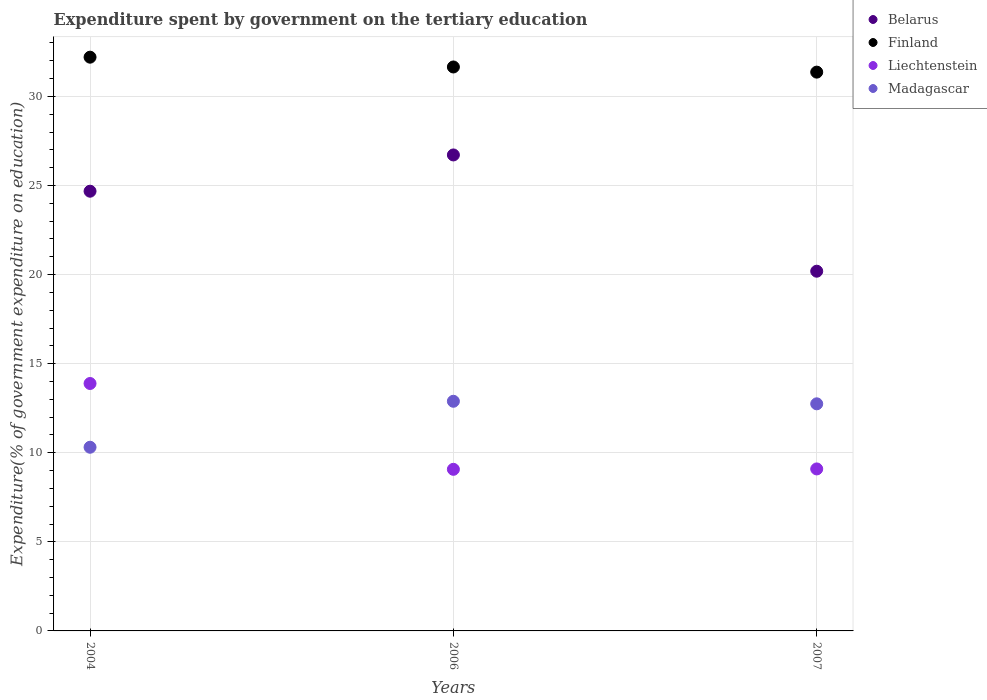What is the expenditure spent by government on the tertiary education in Finland in 2006?
Your response must be concise. 31.65. Across all years, what is the maximum expenditure spent by government on the tertiary education in Liechtenstein?
Keep it short and to the point. 13.89. Across all years, what is the minimum expenditure spent by government on the tertiary education in Finland?
Your response must be concise. 31.36. What is the total expenditure spent by government on the tertiary education in Finland in the graph?
Give a very brief answer. 95.22. What is the difference between the expenditure spent by government on the tertiary education in Belarus in 2004 and that in 2007?
Provide a short and direct response. 4.49. What is the difference between the expenditure spent by government on the tertiary education in Madagascar in 2004 and the expenditure spent by government on the tertiary education in Liechtenstein in 2007?
Your answer should be very brief. 1.22. What is the average expenditure spent by government on the tertiary education in Belarus per year?
Provide a short and direct response. 23.86. In the year 2007, what is the difference between the expenditure spent by government on the tertiary education in Liechtenstein and expenditure spent by government on the tertiary education in Finland?
Keep it short and to the point. -22.27. What is the ratio of the expenditure spent by government on the tertiary education in Liechtenstein in 2006 to that in 2007?
Your answer should be compact. 1. Is the expenditure spent by government on the tertiary education in Liechtenstein in 2006 less than that in 2007?
Offer a terse response. Yes. What is the difference between the highest and the second highest expenditure spent by government on the tertiary education in Liechtenstein?
Provide a succinct answer. 4.79. What is the difference between the highest and the lowest expenditure spent by government on the tertiary education in Madagascar?
Keep it short and to the point. 2.58. In how many years, is the expenditure spent by government on the tertiary education in Liechtenstein greater than the average expenditure spent by government on the tertiary education in Liechtenstein taken over all years?
Provide a short and direct response. 1. Is the sum of the expenditure spent by government on the tertiary education in Belarus in 2004 and 2007 greater than the maximum expenditure spent by government on the tertiary education in Liechtenstein across all years?
Provide a succinct answer. Yes. Is the expenditure spent by government on the tertiary education in Belarus strictly greater than the expenditure spent by government on the tertiary education in Madagascar over the years?
Provide a succinct answer. Yes. Is the expenditure spent by government on the tertiary education in Liechtenstein strictly less than the expenditure spent by government on the tertiary education in Madagascar over the years?
Give a very brief answer. No. How many legend labels are there?
Ensure brevity in your answer.  4. How are the legend labels stacked?
Offer a very short reply. Vertical. What is the title of the graph?
Provide a succinct answer. Expenditure spent by government on the tertiary education. What is the label or title of the X-axis?
Offer a terse response. Years. What is the label or title of the Y-axis?
Provide a succinct answer. Expenditure(% of government expenditure on education). What is the Expenditure(% of government expenditure on education) of Belarus in 2004?
Offer a terse response. 24.68. What is the Expenditure(% of government expenditure on education) in Finland in 2004?
Your response must be concise. 32.2. What is the Expenditure(% of government expenditure on education) of Liechtenstein in 2004?
Your response must be concise. 13.89. What is the Expenditure(% of government expenditure on education) in Madagascar in 2004?
Offer a terse response. 10.31. What is the Expenditure(% of government expenditure on education) in Belarus in 2006?
Provide a succinct answer. 26.71. What is the Expenditure(% of government expenditure on education) in Finland in 2006?
Offer a very short reply. 31.65. What is the Expenditure(% of government expenditure on education) of Liechtenstein in 2006?
Your answer should be very brief. 9.07. What is the Expenditure(% of government expenditure on education) of Madagascar in 2006?
Keep it short and to the point. 12.89. What is the Expenditure(% of government expenditure on education) of Belarus in 2007?
Keep it short and to the point. 20.19. What is the Expenditure(% of government expenditure on education) in Finland in 2007?
Give a very brief answer. 31.36. What is the Expenditure(% of government expenditure on education) in Liechtenstein in 2007?
Provide a succinct answer. 9.09. What is the Expenditure(% of government expenditure on education) in Madagascar in 2007?
Ensure brevity in your answer.  12.75. Across all years, what is the maximum Expenditure(% of government expenditure on education) of Belarus?
Your response must be concise. 26.71. Across all years, what is the maximum Expenditure(% of government expenditure on education) in Finland?
Offer a terse response. 32.2. Across all years, what is the maximum Expenditure(% of government expenditure on education) in Liechtenstein?
Your response must be concise. 13.89. Across all years, what is the maximum Expenditure(% of government expenditure on education) in Madagascar?
Your answer should be compact. 12.89. Across all years, what is the minimum Expenditure(% of government expenditure on education) in Belarus?
Give a very brief answer. 20.19. Across all years, what is the minimum Expenditure(% of government expenditure on education) of Finland?
Your answer should be very brief. 31.36. Across all years, what is the minimum Expenditure(% of government expenditure on education) in Liechtenstein?
Offer a very short reply. 9.07. Across all years, what is the minimum Expenditure(% of government expenditure on education) of Madagascar?
Your answer should be very brief. 10.31. What is the total Expenditure(% of government expenditure on education) in Belarus in the graph?
Make the answer very short. 71.58. What is the total Expenditure(% of government expenditure on education) of Finland in the graph?
Ensure brevity in your answer.  95.22. What is the total Expenditure(% of government expenditure on education) in Liechtenstein in the graph?
Keep it short and to the point. 32.05. What is the total Expenditure(% of government expenditure on education) of Madagascar in the graph?
Provide a short and direct response. 35.95. What is the difference between the Expenditure(% of government expenditure on education) of Belarus in 2004 and that in 2006?
Provide a short and direct response. -2.04. What is the difference between the Expenditure(% of government expenditure on education) of Finland in 2004 and that in 2006?
Make the answer very short. 0.55. What is the difference between the Expenditure(% of government expenditure on education) in Liechtenstein in 2004 and that in 2006?
Offer a very short reply. 4.82. What is the difference between the Expenditure(% of government expenditure on education) in Madagascar in 2004 and that in 2006?
Ensure brevity in your answer.  -2.58. What is the difference between the Expenditure(% of government expenditure on education) in Belarus in 2004 and that in 2007?
Offer a very short reply. 4.49. What is the difference between the Expenditure(% of government expenditure on education) in Finland in 2004 and that in 2007?
Offer a terse response. 0.84. What is the difference between the Expenditure(% of government expenditure on education) of Liechtenstein in 2004 and that in 2007?
Your answer should be compact. 4.79. What is the difference between the Expenditure(% of government expenditure on education) of Madagascar in 2004 and that in 2007?
Offer a very short reply. -2.44. What is the difference between the Expenditure(% of government expenditure on education) in Belarus in 2006 and that in 2007?
Make the answer very short. 6.53. What is the difference between the Expenditure(% of government expenditure on education) of Finland in 2006 and that in 2007?
Give a very brief answer. 0.29. What is the difference between the Expenditure(% of government expenditure on education) in Liechtenstein in 2006 and that in 2007?
Give a very brief answer. -0.02. What is the difference between the Expenditure(% of government expenditure on education) in Madagascar in 2006 and that in 2007?
Provide a short and direct response. 0.14. What is the difference between the Expenditure(% of government expenditure on education) of Belarus in 2004 and the Expenditure(% of government expenditure on education) of Finland in 2006?
Keep it short and to the point. -6.97. What is the difference between the Expenditure(% of government expenditure on education) of Belarus in 2004 and the Expenditure(% of government expenditure on education) of Liechtenstein in 2006?
Keep it short and to the point. 15.61. What is the difference between the Expenditure(% of government expenditure on education) of Belarus in 2004 and the Expenditure(% of government expenditure on education) of Madagascar in 2006?
Provide a short and direct response. 11.79. What is the difference between the Expenditure(% of government expenditure on education) in Finland in 2004 and the Expenditure(% of government expenditure on education) in Liechtenstein in 2006?
Your response must be concise. 23.13. What is the difference between the Expenditure(% of government expenditure on education) of Finland in 2004 and the Expenditure(% of government expenditure on education) of Madagascar in 2006?
Make the answer very short. 19.31. What is the difference between the Expenditure(% of government expenditure on education) in Belarus in 2004 and the Expenditure(% of government expenditure on education) in Finland in 2007?
Your response must be concise. -6.68. What is the difference between the Expenditure(% of government expenditure on education) of Belarus in 2004 and the Expenditure(% of government expenditure on education) of Liechtenstein in 2007?
Keep it short and to the point. 15.59. What is the difference between the Expenditure(% of government expenditure on education) in Belarus in 2004 and the Expenditure(% of government expenditure on education) in Madagascar in 2007?
Provide a succinct answer. 11.93. What is the difference between the Expenditure(% of government expenditure on education) in Finland in 2004 and the Expenditure(% of government expenditure on education) in Liechtenstein in 2007?
Make the answer very short. 23.11. What is the difference between the Expenditure(% of government expenditure on education) of Finland in 2004 and the Expenditure(% of government expenditure on education) of Madagascar in 2007?
Provide a succinct answer. 19.45. What is the difference between the Expenditure(% of government expenditure on education) in Liechtenstein in 2004 and the Expenditure(% of government expenditure on education) in Madagascar in 2007?
Offer a very short reply. 1.14. What is the difference between the Expenditure(% of government expenditure on education) in Belarus in 2006 and the Expenditure(% of government expenditure on education) in Finland in 2007?
Your answer should be compact. -4.65. What is the difference between the Expenditure(% of government expenditure on education) in Belarus in 2006 and the Expenditure(% of government expenditure on education) in Liechtenstein in 2007?
Give a very brief answer. 17.62. What is the difference between the Expenditure(% of government expenditure on education) of Belarus in 2006 and the Expenditure(% of government expenditure on education) of Madagascar in 2007?
Offer a terse response. 13.97. What is the difference between the Expenditure(% of government expenditure on education) in Finland in 2006 and the Expenditure(% of government expenditure on education) in Liechtenstein in 2007?
Keep it short and to the point. 22.56. What is the difference between the Expenditure(% of government expenditure on education) of Finland in 2006 and the Expenditure(% of government expenditure on education) of Madagascar in 2007?
Ensure brevity in your answer.  18.91. What is the difference between the Expenditure(% of government expenditure on education) in Liechtenstein in 2006 and the Expenditure(% of government expenditure on education) in Madagascar in 2007?
Your answer should be very brief. -3.68. What is the average Expenditure(% of government expenditure on education) in Belarus per year?
Keep it short and to the point. 23.86. What is the average Expenditure(% of government expenditure on education) of Finland per year?
Your answer should be compact. 31.74. What is the average Expenditure(% of government expenditure on education) of Liechtenstein per year?
Provide a succinct answer. 10.68. What is the average Expenditure(% of government expenditure on education) of Madagascar per year?
Keep it short and to the point. 11.98. In the year 2004, what is the difference between the Expenditure(% of government expenditure on education) of Belarus and Expenditure(% of government expenditure on education) of Finland?
Provide a succinct answer. -7.52. In the year 2004, what is the difference between the Expenditure(% of government expenditure on education) of Belarus and Expenditure(% of government expenditure on education) of Liechtenstein?
Your answer should be very brief. 10.79. In the year 2004, what is the difference between the Expenditure(% of government expenditure on education) of Belarus and Expenditure(% of government expenditure on education) of Madagascar?
Offer a terse response. 14.37. In the year 2004, what is the difference between the Expenditure(% of government expenditure on education) of Finland and Expenditure(% of government expenditure on education) of Liechtenstein?
Make the answer very short. 18.31. In the year 2004, what is the difference between the Expenditure(% of government expenditure on education) in Finland and Expenditure(% of government expenditure on education) in Madagascar?
Provide a succinct answer. 21.89. In the year 2004, what is the difference between the Expenditure(% of government expenditure on education) in Liechtenstein and Expenditure(% of government expenditure on education) in Madagascar?
Offer a terse response. 3.58. In the year 2006, what is the difference between the Expenditure(% of government expenditure on education) of Belarus and Expenditure(% of government expenditure on education) of Finland?
Your answer should be very brief. -4.94. In the year 2006, what is the difference between the Expenditure(% of government expenditure on education) of Belarus and Expenditure(% of government expenditure on education) of Liechtenstein?
Make the answer very short. 17.64. In the year 2006, what is the difference between the Expenditure(% of government expenditure on education) in Belarus and Expenditure(% of government expenditure on education) in Madagascar?
Offer a terse response. 13.83. In the year 2006, what is the difference between the Expenditure(% of government expenditure on education) of Finland and Expenditure(% of government expenditure on education) of Liechtenstein?
Your answer should be compact. 22.58. In the year 2006, what is the difference between the Expenditure(% of government expenditure on education) of Finland and Expenditure(% of government expenditure on education) of Madagascar?
Offer a very short reply. 18.76. In the year 2006, what is the difference between the Expenditure(% of government expenditure on education) in Liechtenstein and Expenditure(% of government expenditure on education) in Madagascar?
Provide a succinct answer. -3.82. In the year 2007, what is the difference between the Expenditure(% of government expenditure on education) of Belarus and Expenditure(% of government expenditure on education) of Finland?
Your answer should be compact. -11.17. In the year 2007, what is the difference between the Expenditure(% of government expenditure on education) of Belarus and Expenditure(% of government expenditure on education) of Liechtenstein?
Provide a succinct answer. 11.1. In the year 2007, what is the difference between the Expenditure(% of government expenditure on education) of Belarus and Expenditure(% of government expenditure on education) of Madagascar?
Provide a succinct answer. 7.44. In the year 2007, what is the difference between the Expenditure(% of government expenditure on education) of Finland and Expenditure(% of government expenditure on education) of Liechtenstein?
Your answer should be compact. 22.27. In the year 2007, what is the difference between the Expenditure(% of government expenditure on education) of Finland and Expenditure(% of government expenditure on education) of Madagascar?
Make the answer very short. 18.62. In the year 2007, what is the difference between the Expenditure(% of government expenditure on education) of Liechtenstein and Expenditure(% of government expenditure on education) of Madagascar?
Your response must be concise. -3.65. What is the ratio of the Expenditure(% of government expenditure on education) in Belarus in 2004 to that in 2006?
Provide a short and direct response. 0.92. What is the ratio of the Expenditure(% of government expenditure on education) in Finland in 2004 to that in 2006?
Provide a succinct answer. 1.02. What is the ratio of the Expenditure(% of government expenditure on education) of Liechtenstein in 2004 to that in 2006?
Give a very brief answer. 1.53. What is the ratio of the Expenditure(% of government expenditure on education) in Madagascar in 2004 to that in 2006?
Offer a very short reply. 0.8. What is the ratio of the Expenditure(% of government expenditure on education) in Belarus in 2004 to that in 2007?
Keep it short and to the point. 1.22. What is the ratio of the Expenditure(% of government expenditure on education) in Finland in 2004 to that in 2007?
Your answer should be compact. 1.03. What is the ratio of the Expenditure(% of government expenditure on education) in Liechtenstein in 2004 to that in 2007?
Your answer should be compact. 1.53. What is the ratio of the Expenditure(% of government expenditure on education) of Madagascar in 2004 to that in 2007?
Keep it short and to the point. 0.81. What is the ratio of the Expenditure(% of government expenditure on education) of Belarus in 2006 to that in 2007?
Ensure brevity in your answer.  1.32. What is the ratio of the Expenditure(% of government expenditure on education) of Finland in 2006 to that in 2007?
Your answer should be very brief. 1.01. What is the ratio of the Expenditure(% of government expenditure on education) of Liechtenstein in 2006 to that in 2007?
Offer a very short reply. 1. What is the ratio of the Expenditure(% of government expenditure on education) in Madagascar in 2006 to that in 2007?
Give a very brief answer. 1.01. What is the difference between the highest and the second highest Expenditure(% of government expenditure on education) in Belarus?
Your answer should be very brief. 2.04. What is the difference between the highest and the second highest Expenditure(% of government expenditure on education) in Finland?
Offer a very short reply. 0.55. What is the difference between the highest and the second highest Expenditure(% of government expenditure on education) in Liechtenstein?
Give a very brief answer. 4.79. What is the difference between the highest and the second highest Expenditure(% of government expenditure on education) in Madagascar?
Make the answer very short. 0.14. What is the difference between the highest and the lowest Expenditure(% of government expenditure on education) in Belarus?
Ensure brevity in your answer.  6.53. What is the difference between the highest and the lowest Expenditure(% of government expenditure on education) in Finland?
Your response must be concise. 0.84. What is the difference between the highest and the lowest Expenditure(% of government expenditure on education) of Liechtenstein?
Provide a succinct answer. 4.82. What is the difference between the highest and the lowest Expenditure(% of government expenditure on education) of Madagascar?
Provide a short and direct response. 2.58. 